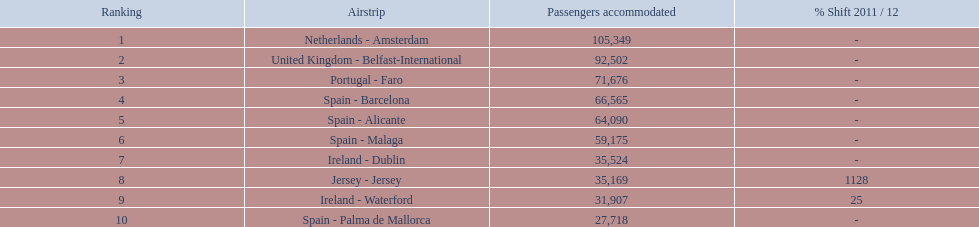Name all the london southend airports that did not list a change in 2001/12. Netherlands - Amsterdam, United Kingdom - Belfast-International, Portugal - Faro, Spain - Barcelona, Spain - Alicante, Spain - Malaga, Ireland - Dublin, Spain - Palma de Mallorca. What unchanged percentage airports from 2011/12 handled less then 50,000 passengers? Ireland - Dublin, Spain - Palma de Mallorca. What unchanged percentage airport from 2011/12 handled less then 50,000 passengers is the closest to the equator? Spain - Palma de Mallorca. 